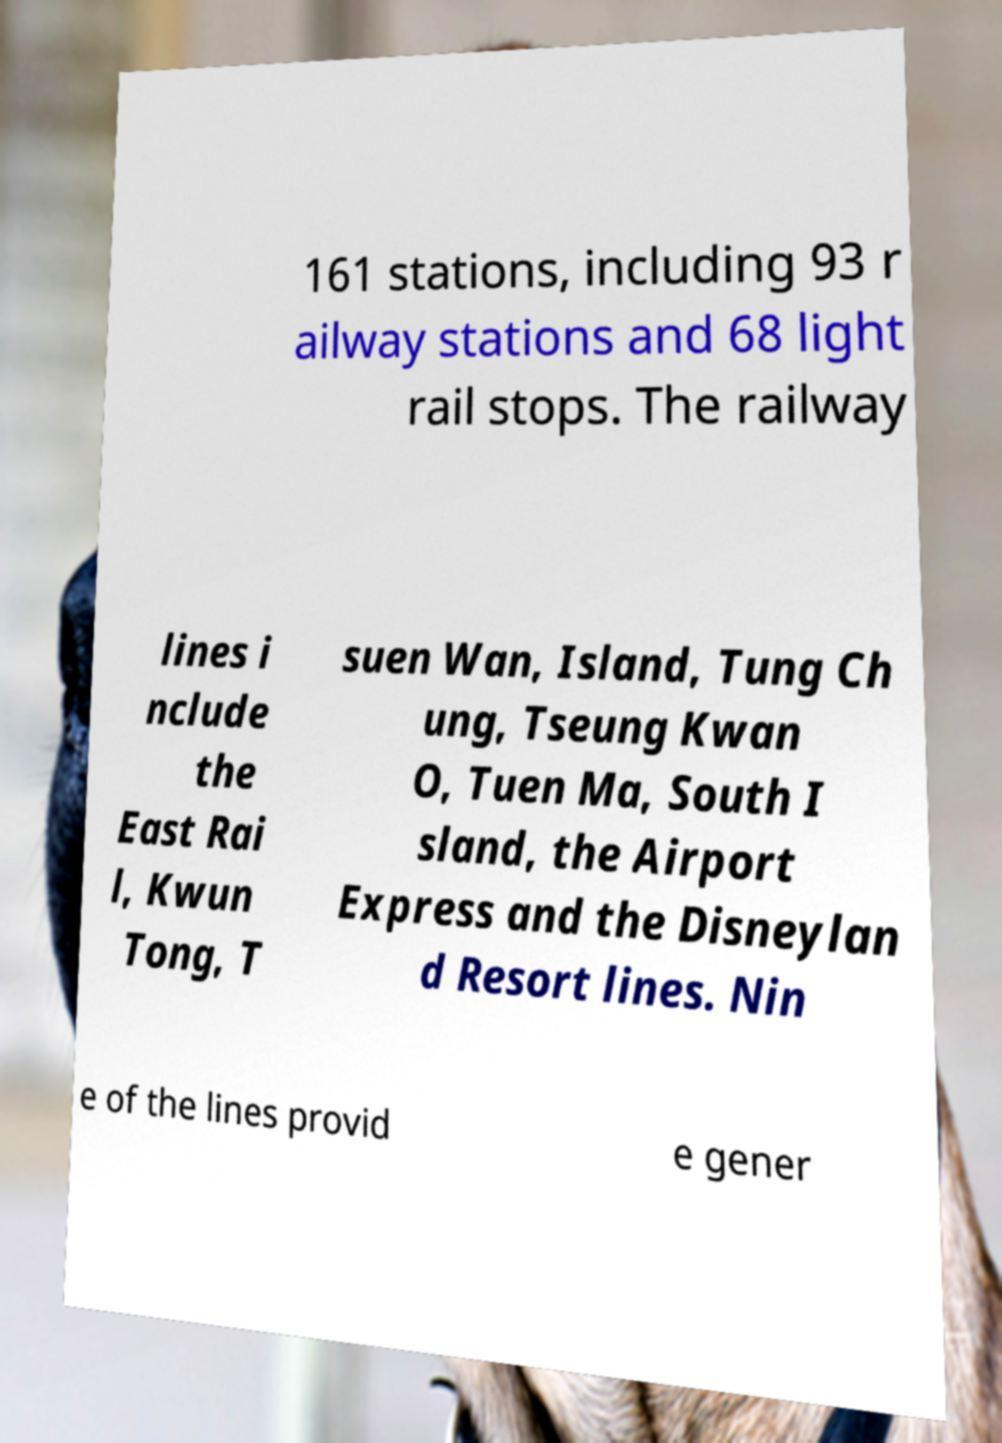Could you assist in decoding the text presented in this image and type it out clearly? 161 stations, including 93 r ailway stations and 68 light rail stops. The railway lines i nclude the East Rai l, Kwun Tong, T suen Wan, Island, Tung Ch ung, Tseung Kwan O, Tuen Ma, South I sland, the Airport Express and the Disneylan d Resort lines. Nin e of the lines provid e gener 